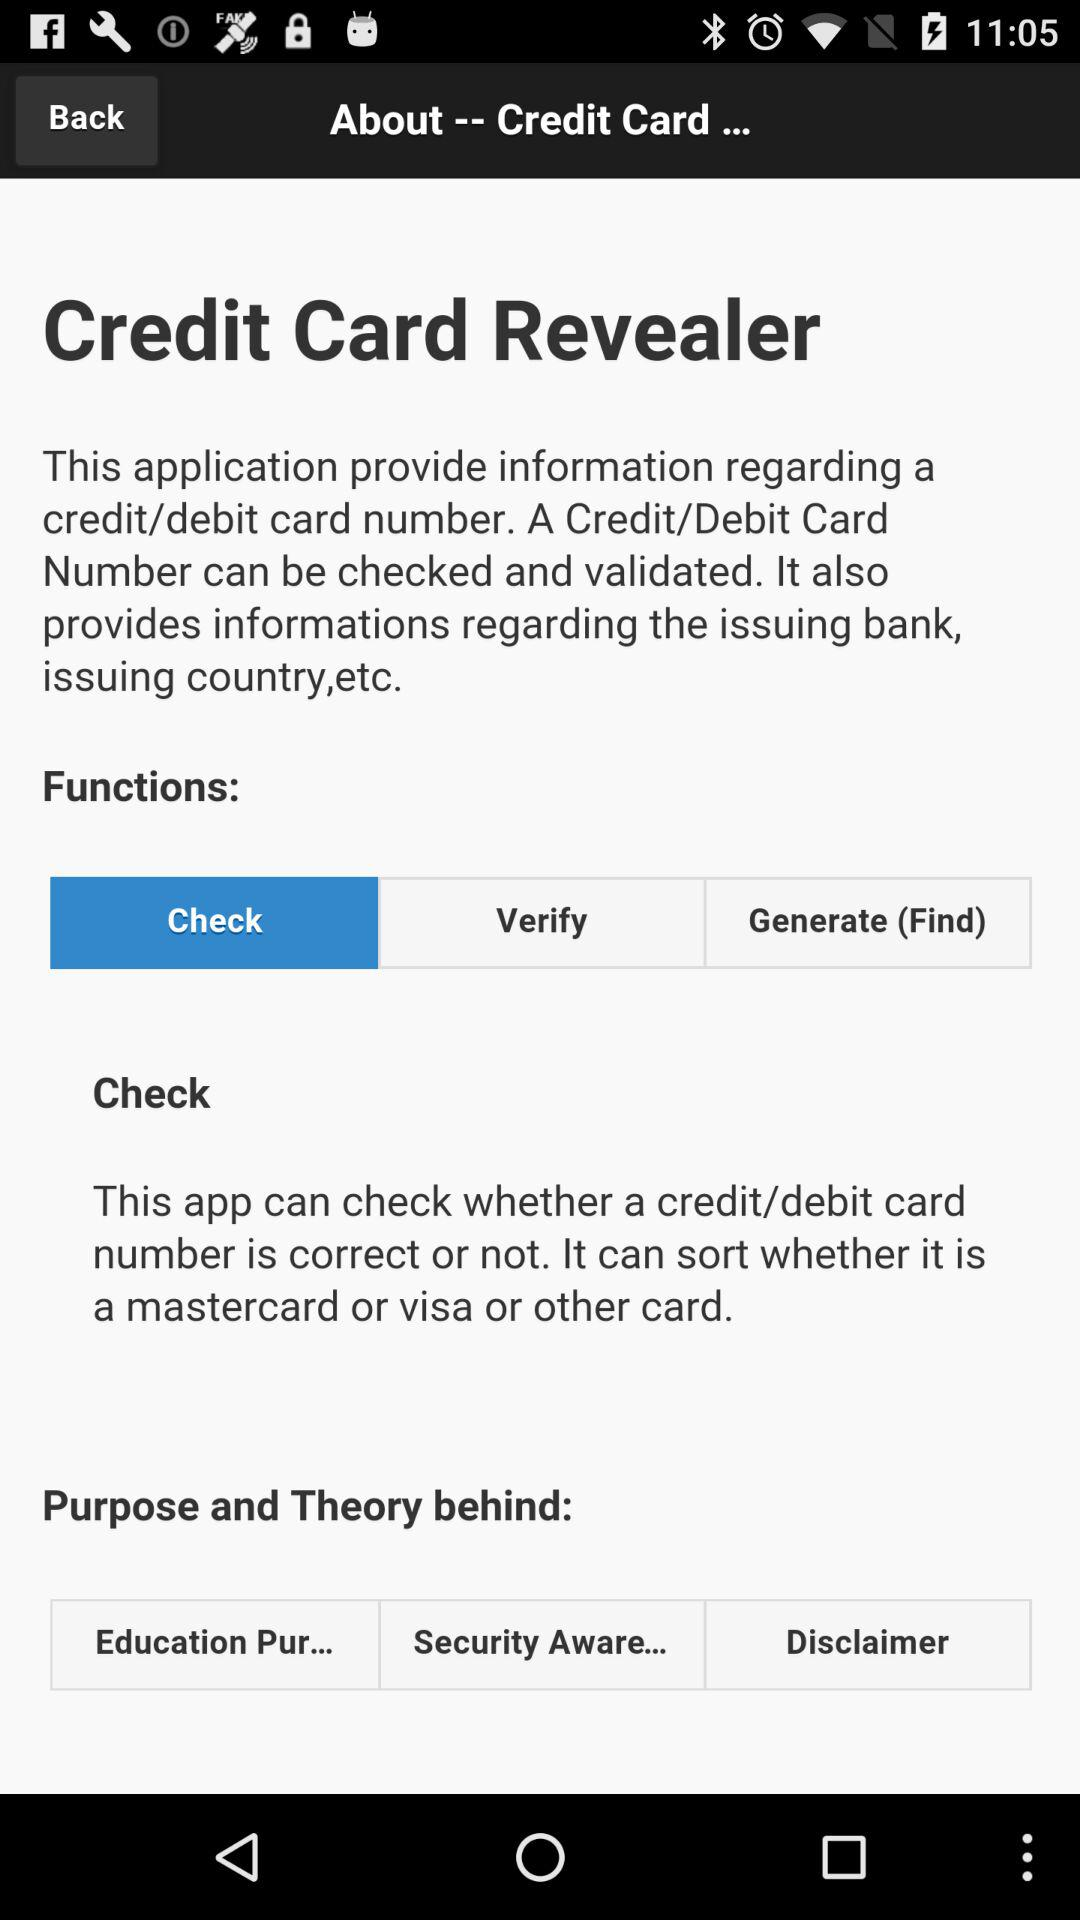Which "Purpose and Theory behind" option is selected?
When the provided information is insufficient, respond with <no answer>. <no answer> 